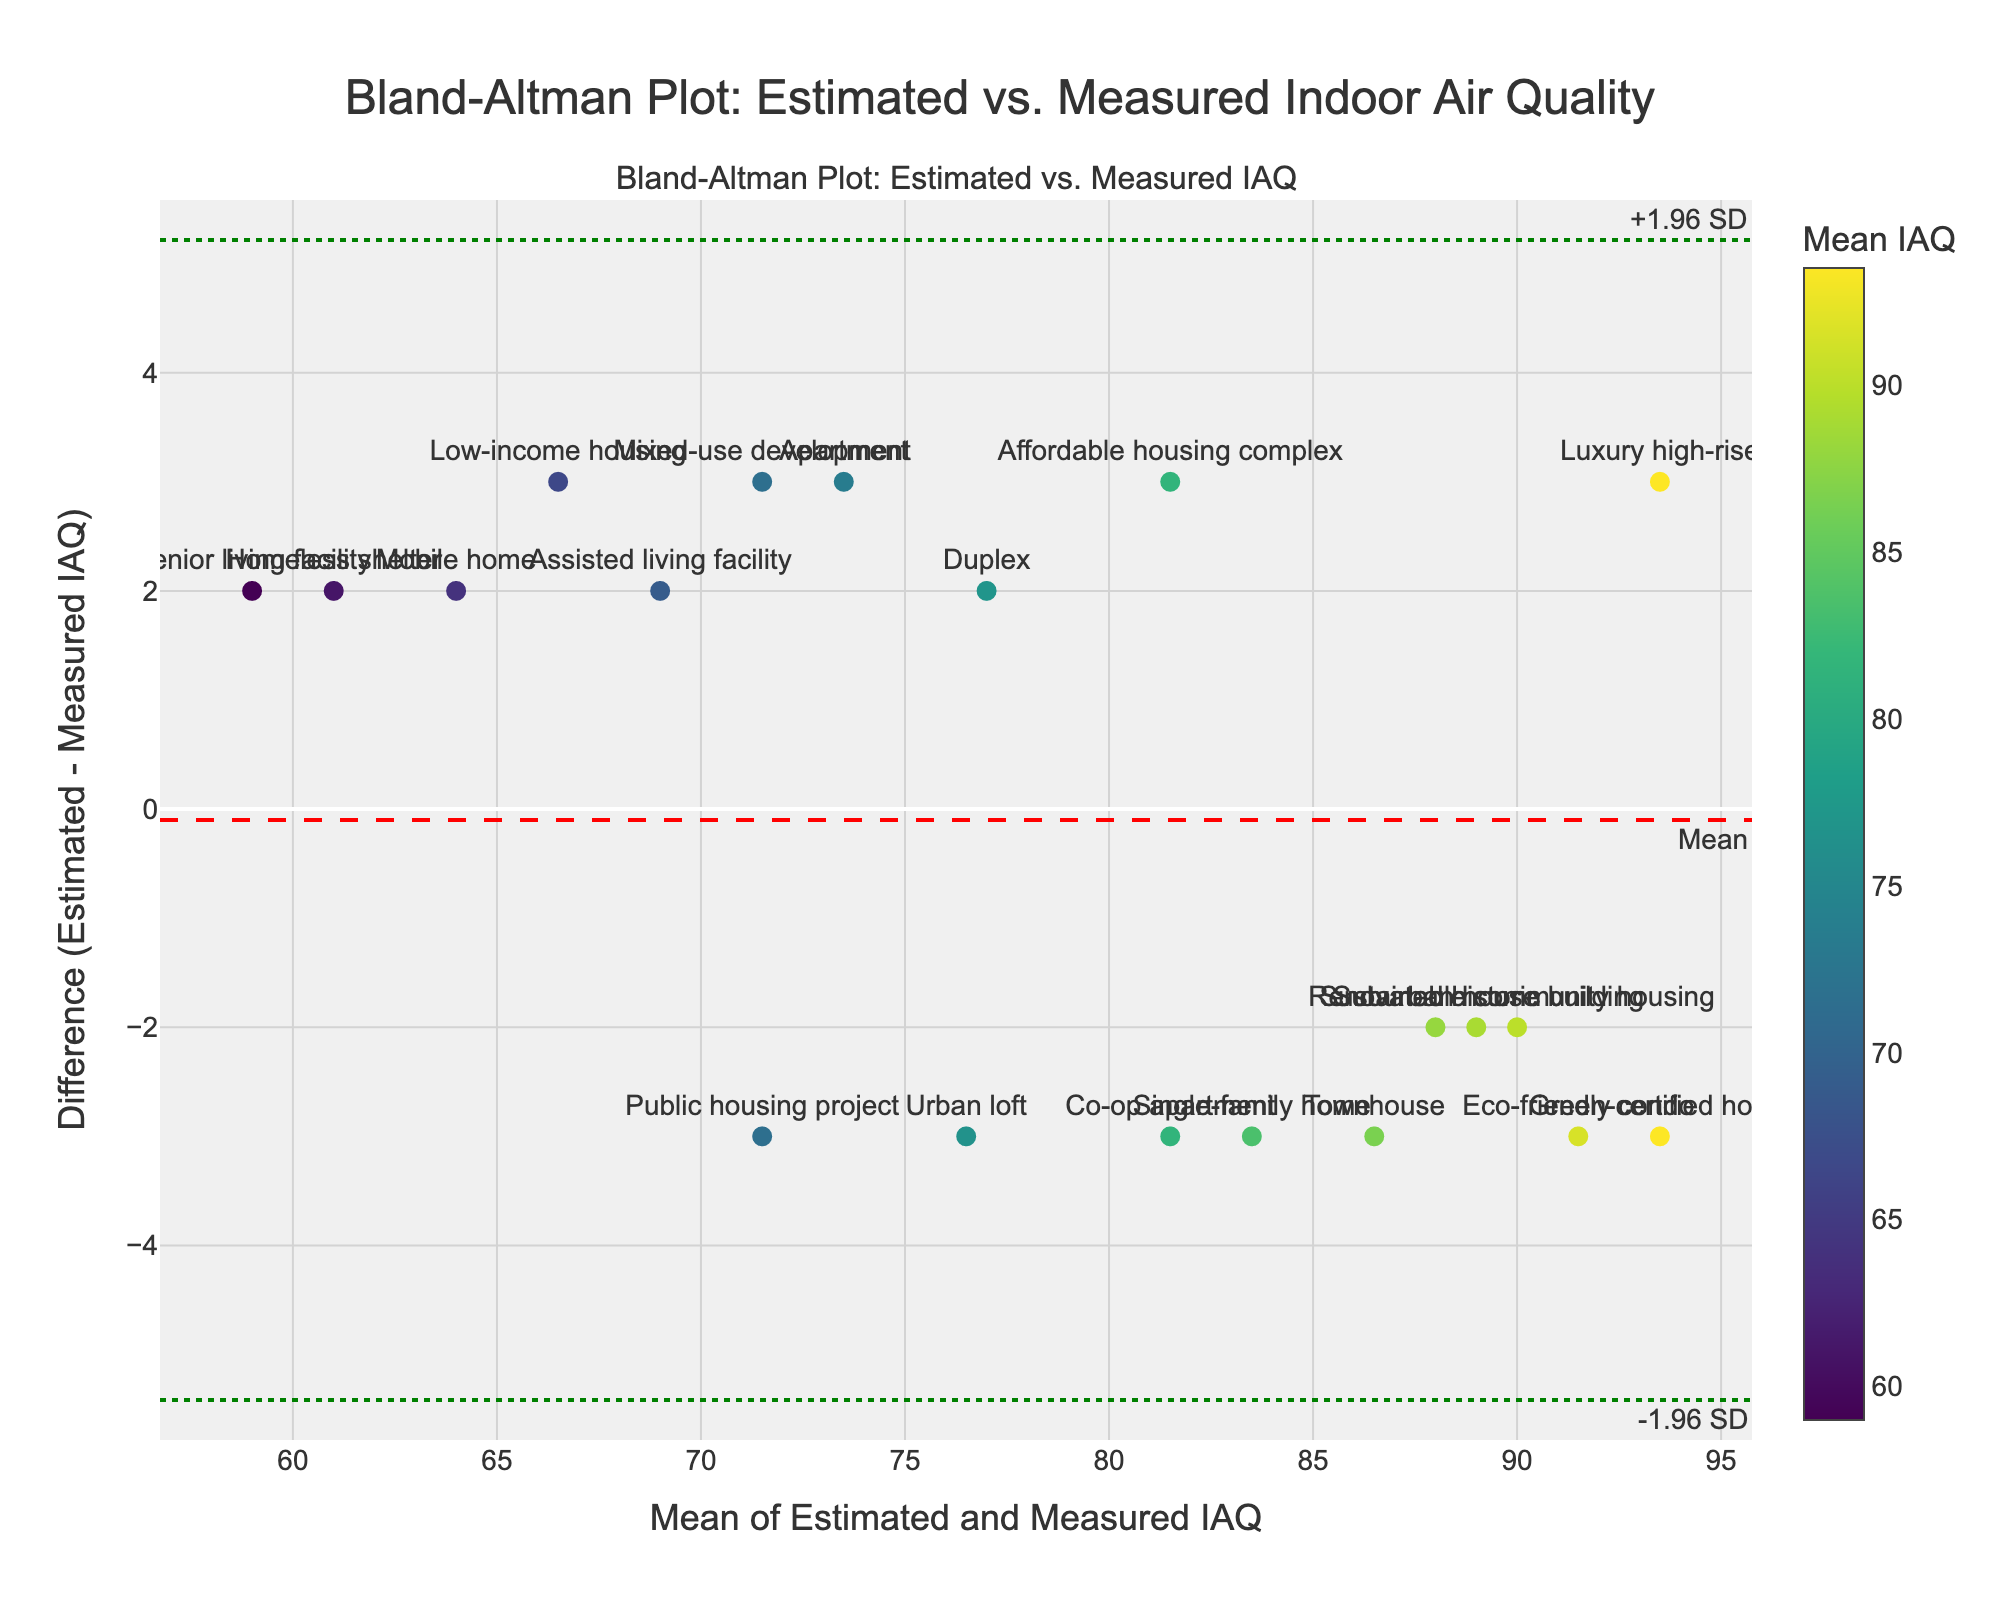What is the title of the plot? The title of the plot is written at the top and center of the figure. It reads "Bland-Altman Plot: Estimated vs. Measured Indoor Air Quality".
Answer: Bland-Altman Plot: Estimated vs. Measured Indoor Air Quality How many different housing types are represented in the plot? Count the number of unique labels for housing types in the scatter plot. There are 20 labels visible.
Answer: 20 Which housing type has the greatest difference between estimated and measured IAQ? Look for the point with the largest vertical distance from the mean difference line. The "Urban loft" with a difference of -3 (Estimated 75, Measured 78) has one of the largest differences.
Answer: Urban loft What is the mean difference between estimated and measured IAQ? The mean difference is represented by the red dashed line labeled "Mean". The y-value of this line is 0.4.
Answer: 0.4 What are the limits of agreement in this plot? The limits of agreement are shown as green dotted lines with annotations at the top and bottom. They are approximately -2.93 (lower limit) and 3.73 (upper limit).
Answer: -2.93 and 3.73 Which housing type has a mean IAQ closest to 80? Identify the point closest to a mean IAQ of 80 on the x-axis. The "Co-op apartment" is located near a mean IAQ of 80.
Answer: Co-op apartment What color represents higher mean IAQ values in the color scale? Refer to the color scale legend on the right of the plot. Darker shades of green towards the top indicate higher mean IAQ values.
Answer: Darker shades of green How many housing types have a positive difference, indicating estimated IAQ is higher than measured IAQ? Count the data points above the y=0 line, indicating positive differences. 10 points are above the line.
Answer: 10 Is the mean difference between estimated and measured IAQ statistically significant? Check if the mean difference (red dashed line) falls within the limits of agreement (green dotted lines). Since the mean difference (0.4) is within the limits (-2.93 and 3.73), it suggests no significant systematic bias.
Answer: No Which housing type has an estimated IAQ that is exactly 3 units higher than its measured IAQ? Look for the point with a vertical position of 3 on the plot. The "Single-family home" has a difference of 3 (Estimated 82, Measured 85).
Answer: Single-family home 